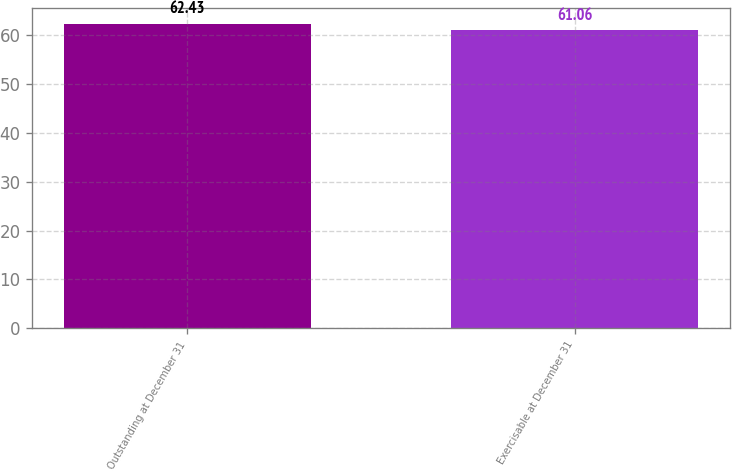Convert chart to OTSL. <chart><loc_0><loc_0><loc_500><loc_500><bar_chart><fcel>Outstanding at December 31<fcel>Exercisable at December 31<nl><fcel>62.43<fcel>61.06<nl></chart> 